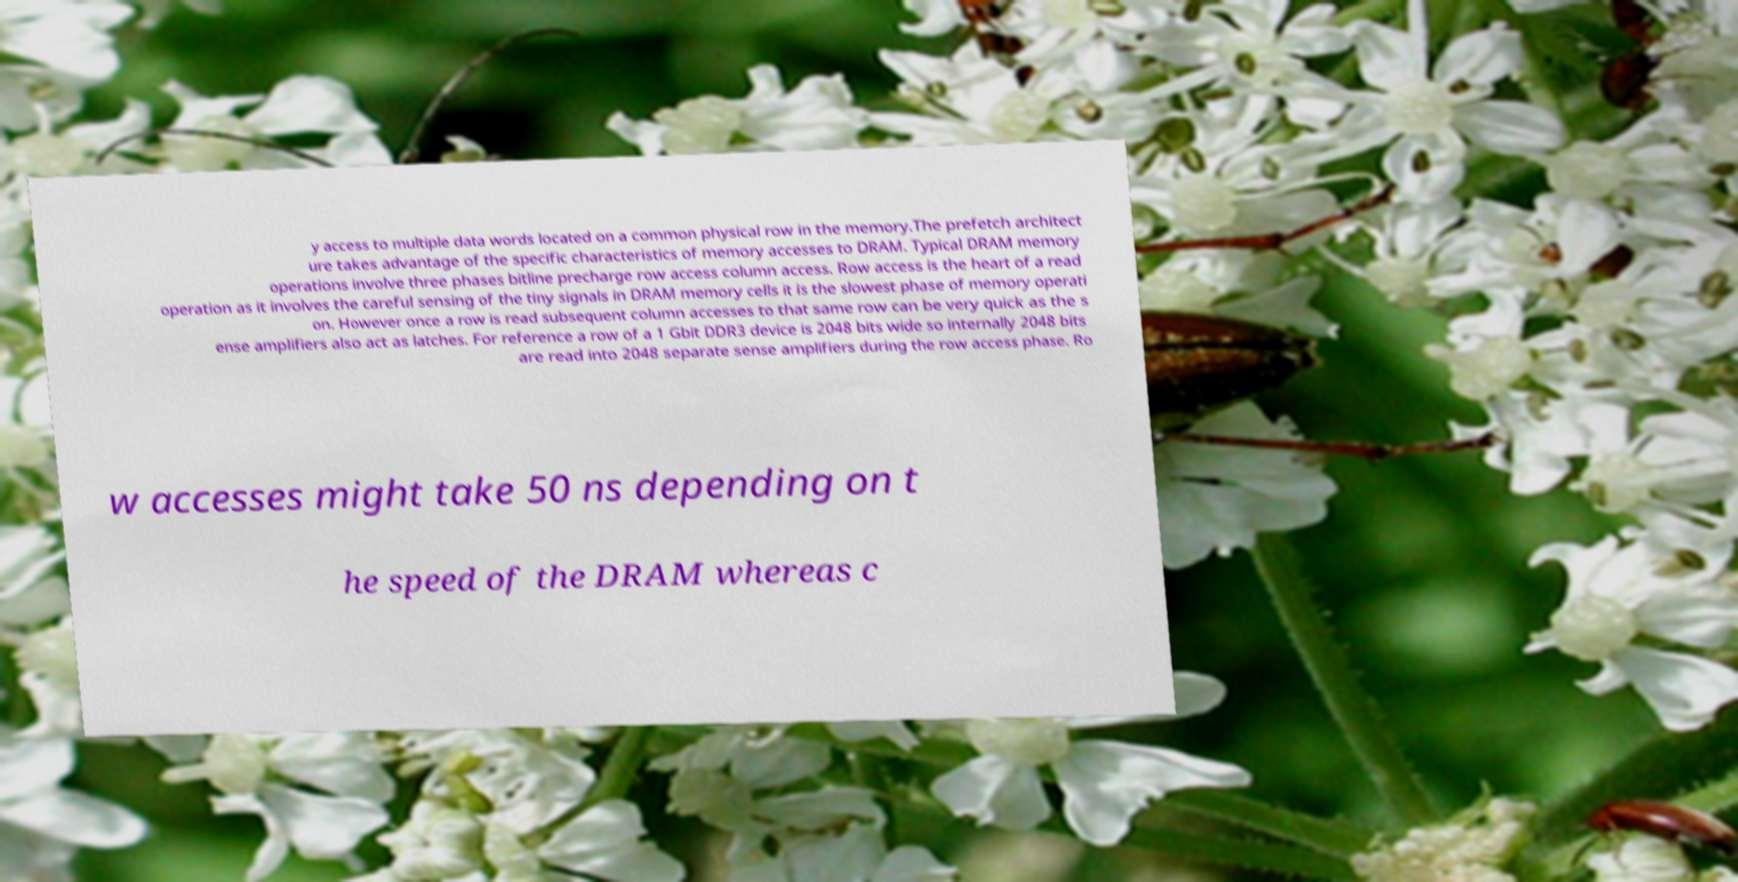Can you read and provide the text displayed in the image?This photo seems to have some interesting text. Can you extract and type it out for me? y access to multiple data words located on a common physical row in the memory.The prefetch architect ure takes advantage of the specific characteristics of memory accesses to DRAM. Typical DRAM memory operations involve three phases bitline precharge row access column access. Row access is the heart of a read operation as it involves the careful sensing of the tiny signals in DRAM memory cells it is the slowest phase of memory operati on. However once a row is read subsequent column accesses to that same row can be very quick as the s ense amplifiers also act as latches. For reference a row of a 1 Gbit DDR3 device is 2048 bits wide so internally 2048 bits are read into 2048 separate sense amplifiers during the row access phase. Ro w accesses might take 50 ns depending on t he speed of the DRAM whereas c 